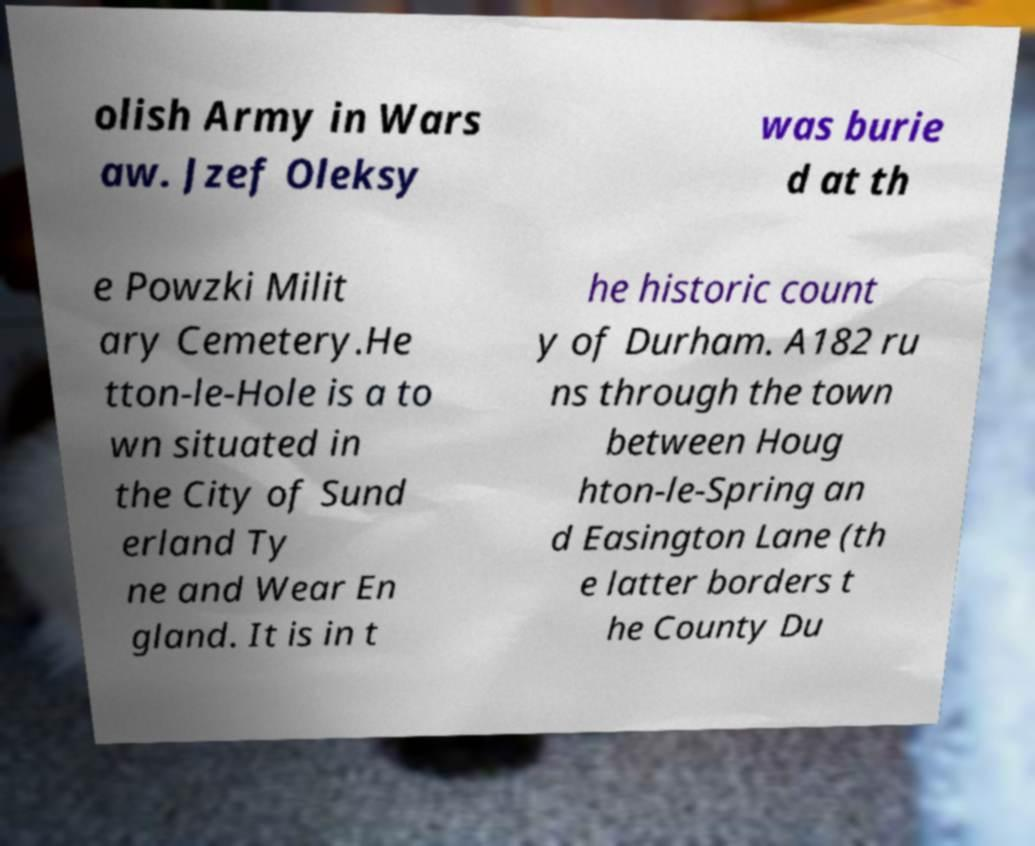Can you read and provide the text displayed in the image?This photo seems to have some interesting text. Can you extract and type it out for me? olish Army in Wars aw. Jzef Oleksy was burie d at th e Powzki Milit ary Cemetery.He tton-le-Hole is a to wn situated in the City of Sund erland Ty ne and Wear En gland. It is in t he historic count y of Durham. A182 ru ns through the town between Houg hton-le-Spring an d Easington Lane (th e latter borders t he County Du 